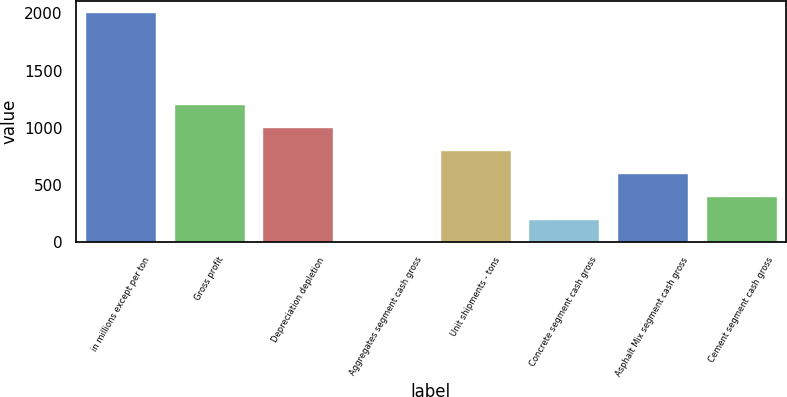Convert chart. <chart><loc_0><loc_0><loc_500><loc_500><bar_chart><fcel>in millions except per ton<fcel>Gross profit<fcel>Depreciation depletion<fcel>Aggregates segment cash gross<fcel>Unit shipments - tons<fcel>Concrete segment cash gross<fcel>Asphalt Mix segment cash gross<fcel>Cement segment cash gross<nl><fcel>2011<fcel>1208.21<fcel>1007.51<fcel>4.01<fcel>806.81<fcel>204.71<fcel>606.11<fcel>405.41<nl></chart> 